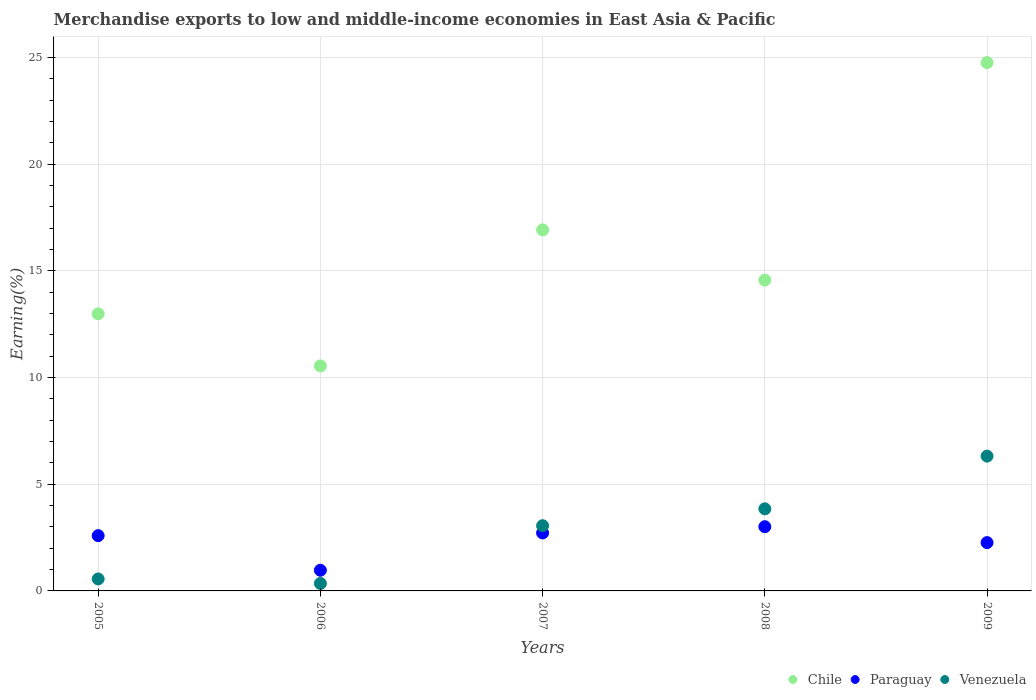How many different coloured dotlines are there?
Your answer should be very brief. 3. What is the percentage of amount earned from merchandise exports in Paraguay in 2008?
Your response must be concise. 3.01. Across all years, what is the maximum percentage of amount earned from merchandise exports in Chile?
Your response must be concise. 24.76. Across all years, what is the minimum percentage of amount earned from merchandise exports in Chile?
Your response must be concise. 10.54. What is the total percentage of amount earned from merchandise exports in Paraguay in the graph?
Ensure brevity in your answer.  11.55. What is the difference between the percentage of amount earned from merchandise exports in Chile in 2006 and that in 2008?
Offer a terse response. -4.02. What is the difference between the percentage of amount earned from merchandise exports in Venezuela in 2006 and the percentage of amount earned from merchandise exports in Paraguay in 2005?
Make the answer very short. -2.24. What is the average percentage of amount earned from merchandise exports in Chile per year?
Keep it short and to the point. 15.95. In the year 2006, what is the difference between the percentage of amount earned from merchandise exports in Paraguay and percentage of amount earned from merchandise exports in Venezuela?
Offer a terse response. 0.62. In how many years, is the percentage of amount earned from merchandise exports in Chile greater than 2 %?
Ensure brevity in your answer.  5. What is the ratio of the percentage of amount earned from merchandise exports in Paraguay in 2005 to that in 2006?
Your response must be concise. 2.68. What is the difference between the highest and the second highest percentage of amount earned from merchandise exports in Chile?
Your response must be concise. 7.84. What is the difference between the highest and the lowest percentage of amount earned from merchandise exports in Paraguay?
Provide a short and direct response. 2.04. In how many years, is the percentage of amount earned from merchandise exports in Paraguay greater than the average percentage of amount earned from merchandise exports in Paraguay taken over all years?
Give a very brief answer. 3. Is the sum of the percentage of amount earned from merchandise exports in Paraguay in 2008 and 2009 greater than the maximum percentage of amount earned from merchandise exports in Chile across all years?
Make the answer very short. No. Is it the case that in every year, the sum of the percentage of amount earned from merchandise exports in Venezuela and percentage of amount earned from merchandise exports in Paraguay  is greater than the percentage of amount earned from merchandise exports in Chile?
Keep it short and to the point. No. Does the percentage of amount earned from merchandise exports in Venezuela monotonically increase over the years?
Offer a very short reply. No. Is the percentage of amount earned from merchandise exports in Venezuela strictly less than the percentage of amount earned from merchandise exports in Chile over the years?
Your answer should be compact. Yes. Are the values on the major ticks of Y-axis written in scientific E-notation?
Provide a succinct answer. No. Does the graph contain any zero values?
Give a very brief answer. No. Where does the legend appear in the graph?
Provide a succinct answer. Bottom right. How are the legend labels stacked?
Provide a succinct answer. Horizontal. What is the title of the graph?
Provide a succinct answer. Merchandise exports to low and middle-income economies in East Asia & Pacific. Does "Least developed countries" appear as one of the legend labels in the graph?
Your answer should be compact. No. What is the label or title of the Y-axis?
Provide a short and direct response. Earning(%). What is the Earning(%) in Chile in 2005?
Provide a succinct answer. 12.98. What is the Earning(%) of Paraguay in 2005?
Offer a very short reply. 2.59. What is the Earning(%) in Venezuela in 2005?
Provide a succinct answer. 0.56. What is the Earning(%) of Chile in 2006?
Your answer should be very brief. 10.54. What is the Earning(%) of Paraguay in 2006?
Your response must be concise. 0.97. What is the Earning(%) in Venezuela in 2006?
Ensure brevity in your answer.  0.35. What is the Earning(%) of Chile in 2007?
Your response must be concise. 16.92. What is the Earning(%) in Paraguay in 2007?
Your answer should be compact. 2.72. What is the Earning(%) of Venezuela in 2007?
Offer a terse response. 3.06. What is the Earning(%) of Chile in 2008?
Offer a very short reply. 14.57. What is the Earning(%) of Paraguay in 2008?
Make the answer very short. 3.01. What is the Earning(%) in Venezuela in 2008?
Provide a short and direct response. 3.85. What is the Earning(%) in Chile in 2009?
Make the answer very short. 24.76. What is the Earning(%) in Paraguay in 2009?
Provide a succinct answer. 2.26. What is the Earning(%) of Venezuela in 2009?
Give a very brief answer. 6.32. Across all years, what is the maximum Earning(%) in Chile?
Offer a very short reply. 24.76. Across all years, what is the maximum Earning(%) of Paraguay?
Your answer should be very brief. 3.01. Across all years, what is the maximum Earning(%) in Venezuela?
Ensure brevity in your answer.  6.32. Across all years, what is the minimum Earning(%) in Chile?
Ensure brevity in your answer.  10.54. Across all years, what is the minimum Earning(%) in Paraguay?
Offer a terse response. 0.97. Across all years, what is the minimum Earning(%) of Venezuela?
Offer a very short reply. 0.35. What is the total Earning(%) of Chile in the graph?
Keep it short and to the point. 79.77. What is the total Earning(%) of Paraguay in the graph?
Make the answer very short. 11.55. What is the total Earning(%) of Venezuela in the graph?
Offer a terse response. 14.13. What is the difference between the Earning(%) of Chile in 2005 and that in 2006?
Keep it short and to the point. 2.44. What is the difference between the Earning(%) in Paraguay in 2005 and that in 2006?
Provide a succinct answer. 1.62. What is the difference between the Earning(%) of Venezuela in 2005 and that in 2006?
Ensure brevity in your answer.  0.21. What is the difference between the Earning(%) in Chile in 2005 and that in 2007?
Your answer should be compact. -3.93. What is the difference between the Earning(%) of Paraguay in 2005 and that in 2007?
Keep it short and to the point. -0.13. What is the difference between the Earning(%) of Venezuela in 2005 and that in 2007?
Keep it short and to the point. -2.49. What is the difference between the Earning(%) in Chile in 2005 and that in 2008?
Your answer should be compact. -1.58. What is the difference between the Earning(%) in Paraguay in 2005 and that in 2008?
Your response must be concise. -0.42. What is the difference between the Earning(%) of Venezuela in 2005 and that in 2008?
Provide a succinct answer. -3.29. What is the difference between the Earning(%) in Chile in 2005 and that in 2009?
Your answer should be compact. -11.77. What is the difference between the Earning(%) of Paraguay in 2005 and that in 2009?
Provide a succinct answer. 0.33. What is the difference between the Earning(%) of Venezuela in 2005 and that in 2009?
Your answer should be very brief. -5.75. What is the difference between the Earning(%) in Chile in 2006 and that in 2007?
Give a very brief answer. -6.37. What is the difference between the Earning(%) of Paraguay in 2006 and that in 2007?
Your answer should be very brief. -1.75. What is the difference between the Earning(%) of Venezuela in 2006 and that in 2007?
Offer a very short reply. -2.71. What is the difference between the Earning(%) of Chile in 2006 and that in 2008?
Provide a succinct answer. -4.02. What is the difference between the Earning(%) of Paraguay in 2006 and that in 2008?
Offer a very short reply. -2.04. What is the difference between the Earning(%) in Venezuela in 2006 and that in 2008?
Keep it short and to the point. -3.5. What is the difference between the Earning(%) of Chile in 2006 and that in 2009?
Your answer should be compact. -14.21. What is the difference between the Earning(%) of Paraguay in 2006 and that in 2009?
Give a very brief answer. -1.3. What is the difference between the Earning(%) in Venezuela in 2006 and that in 2009?
Make the answer very short. -5.97. What is the difference between the Earning(%) of Chile in 2007 and that in 2008?
Give a very brief answer. 2.35. What is the difference between the Earning(%) in Paraguay in 2007 and that in 2008?
Provide a succinct answer. -0.29. What is the difference between the Earning(%) in Venezuela in 2007 and that in 2008?
Offer a very short reply. -0.79. What is the difference between the Earning(%) of Chile in 2007 and that in 2009?
Give a very brief answer. -7.84. What is the difference between the Earning(%) in Paraguay in 2007 and that in 2009?
Make the answer very short. 0.45. What is the difference between the Earning(%) of Venezuela in 2007 and that in 2009?
Your response must be concise. -3.26. What is the difference between the Earning(%) in Chile in 2008 and that in 2009?
Provide a succinct answer. -10.19. What is the difference between the Earning(%) of Paraguay in 2008 and that in 2009?
Offer a terse response. 0.75. What is the difference between the Earning(%) of Venezuela in 2008 and that in 2009?
Provide a short and direct response. -2.47. What is the difference between the Earning(%) of Chile in 2005 and the Earning(%) of Paraguay in 2006?
Your answer should be compact. 12.02. What is the difference between the Earning(%) of Chile in 2005 and the Earning(%) of Venezuela in 2006?
Give a very brief answer. 12.64. What is the difference between the Earning(%) of Paraguay in 2005 and the Earning(%) of Venezuela in 2006?
Offer a very short reply. 2.24. What is the difference between the Earning(%) of Chile in 2005 and the Earning(%) of Paraguay in 2007?
Offer a very short reply. 10.27. What is the difference between the Earning(%) in Chile in 2005 and the Earning(%) in Venezuela in 2007?
Provide a succinct answer. 9.93. What is the difference between the Earning(%) in Paraguay in 2005 and the Earning(%) in Venezuela in 2007?
Provide a succinct answer. -0.47. What is the difference between the Earning(%) of Chile in 2005 and the Earning(%) of Paraguay in 2008?
Offer a terse response. 9.97. What is the difference between the Earning(%) in Chile in 2005 and the Earning(%) in Venezuela in 2008?
Your answer should be compact. 9.14. What is the difference between the Earning(%) in Paraguay in 2005 and the Earning(%) in Venezuela in 2008?
Offer a terse response. -1.26. What is the difference between the Earning(%) in Chile in 2005 and the Earning(%) in Paraguay in 2009?
Ensure brevity in your answer.  10.72. What is the difference between the Earning(%) in Chile in 2005 and the Earning(%) in Venezuela in 2009?
Ensure brevity in your answer.  6.67. What is the difference between the Earning(%) in Paraguay in 2005 and the Earning(%) in Venezuela in 2009?
Offer a very short reply. -3.73. What is the difference between the Earning(%) in Chile in 2006 and the Earning(%) in Paraguay in 2007?
Provide a short and direct response. 7.83. What is the difference between the Earning(%) of Chile in 2006 and the Earning(%) of Venezuela in 2007?
Your response must be concise. 7.49. What is the difference between the Earning(%) of Paraguay in 2006 and the Earning(%) of Venezuela in 2007?
Offer a terse response. -2.09. What is the difference between the Earning(%) of Chile in 2006 and the Earning(%) of Paraguay in 2008?
Ensure brevity in your answer.  7.53. What is the difference between the Earning(%) of Chile in 2006 and the Earning(%) of Venezuela in 2008?
Offer a terse response. 6.7. What is the difference between the Earning(%) of Paraguay in 2006 and the Earning(%) of Venezuela in 2008?
Make the answer very short. -2.88. What is the difference between the Earning(%) of Chile in 2006 and the Earning(%) of Paraguay in 2009?
Offer a terse response. 8.28. What is the difference between the Earning(%) of Chile in 2006 and the Earning(%) of Venezuela in 2009?
Offer a terse response. 4.23. What is the difference between the Earning(%) of Paraguay in 2006 and the Earning(%) of Venezuela in 2009?
Your answer should be very brief. -5.35. What is the difference between the Earning(%) of Chile in 2007 and the Earning(%) of Paraguay in 2008?
Offer a very short reply. 13.91. What is the difference between the Earning(%) of Chile in 2007 and the Earning(%) of Venezuela in 2008?
Your answer should be very brief. 13.07. What is the difference between the Earning(%) in Paraguay in 2007 and the Earning(%) in Venezuela in 2008?
Offer a terse response. -1.13. What is the difference between the Earning(%) of Chile in 2007 and the Earning(%) of Paraguay in 2009?
Keep it short and to the point. 14.65. What is the difference between the Earning(%) in Chile in 2007 and the Earning(%) in Venezuela in 2009?
Your answer should be very brief. 10.6. What is the difference between the Earning(%) of Paraguay in 2007 and the Earning(%) of Venezuela in 2009?
Provide a succinct answer. -3.6. What is the difference between the Earning(%) in Chile in 2008 and the Earning(%) in Paraguay in 2009?
Keep it short and to the point. 12.3. What is the difference between the Earning(%) of Chile in 2008 and the Earning(%) of Venezuela in 2009?
Offer a very short reply. 8.25. What is the difference between the Earning(%) of Paraguay in 2008 and the Earning(%) of Venezuela in 2009?
Make the answer very short. -3.31. What is the average Earning(%) of Chile per year?
Provide a succinct answer. 15.95. What is the average Earning(%) in Paraguay per year?
Your answer should be very brief. 2.31. What is the average Earning(%) in Venezuela per year?
Your answer should be compact. 2.83. In the year 2005, what is the difference between the Earning(%) of Chile and Earning(%) of Paraguay?
Provide a short and direct response. 10.4. In the year 2005, what is the difference between the Earning(%) of Chile and Earning(%) of Venezuela?
Provide a short and direct response. 12.42. In the year 2005, what is the difference between the Earning(%) in Paraguay and Earning(%) in Venezuela?
Give a very brief answer. 2.03. In the year 2006, what is the difference between the Earning(%) in Chile and Earning(%) in Paraguay?
Your answer should be very brief. 9.58. In the year 2006, what is the difference between the Earning(%) in Chile and Earning(%) in Venezuela?
Keep it short and to the point. 10.19. In the year 2006, what is the difference between the Earning(%) in Paraguay and Earning(%) in Venezuela?
Keep it short and to the point. 0.62. In the year 2007, what is the difference between the Earning(%) of Chile and Earning(%) of Paraguay?
Your response must be concise. 14.2. In the year 2007, what is the difference between the Earning(%) of Chile and Earning(%) of Venezuela?
Make the answer very short. 13.86. In the year 2007, what is the difference between the Earning(%) in Paraguay and Earning(%) in Venezuela?
Make the answer very short. -0.34. In the year 2008, what is the difference between the Earning(%) in Chile and Earning(%) in Paraguay?
Provide a short and direct response. 11.56. In the year 2008, what is the difference between the Earning(%) of Chile and Earning(%) of Venezuela?
Offer a terse response. 10.72. In the year 2008, what is the difference between the Earning(%) in Paraguay and Earning(%) in Venezuela?
Your response must be concise. -0.84. In the year 2009, what is the difference between the Earning(%) of Chile and Earning(%) of Paraguay?
Give a very brief answer. 22.49. In the year 2009, what is the difference between the Earning(%) of Chile and Earning(%) of Venezuela?
Make the answer very short. 18.44. In the year 2009, what is the difference between the Earning(%) in Paraguay and Earning(%) in Venezuela?
Your answer should be very brief. -4.05. What is the ratio of the Earning(%) of Chile in 2005 to that in 2006?
Your answer should be very brief. 1.23. What is the ratio of the Earning(%) of Paraguay in 2005 to that in 2006?
Provide a succinct answer. 2.68. What is the ratio of the Earning(%) in Venezuela in 2005 to that in 2006?
Ensure brevity in your answer.  1.61. What is the ratio of the Earning(%) of Chile in 2005 to that in 2007?
Ensure brevity in your answer.  0.77. What is the ratio of the Earning(%) of Paraguay in 2005 to that in 2007?
Your response must be concise. 0.95. What is the ratio of the Earning(%) of Venezuela in 2005 to that in 2007?
Your answer should be compact. 0.18. What is the ratio of the Earning(%) in Chile in 2005 to that in 2008?
Give a very brief answer. 0.89. What is the ratio of the Earning(%) in Paraguay in 2005 to that in 2008?
Keep it short and to the point. 0.86. What is the ratio of the Earning(%) in Venezuela in 2005 to that in 2008?
Make the answer very short. 0.15. What is the ratio of the Earning(%) of Chile in 2005 to that in 2009?
Ensure brevity in your answer.  0.52. What is the ratio of the Earning(%) of Paraguay in 2005 to that in 2009?
Keep it short and to the point. 1.14. What is the ratio of the Earning(%) in Venezuela in 2005 to that in 2009?
Provide a succinct answer. 0.09. What is the ratio of the Earning(%) in Chile in 2006 to that in 2007?
Your response must be concise. 0.62. What is the ratio of the Earning(%) of Paraguay in 2006 to that in 2007?
Give a very brief answer. 0.36. What is the ratio of the Earning(%) in Venezuela in 2006 to that in 2007?
Your answer should be compact. 0.11. What is the ratio of the Earning(%) in Chile in 2006 to that in 2008?
Keep it short and to the point. 0.72. What is the ratio of the Earning(%) of Paraguay in 2006 to that in 2008?
Provide a succinct answer. 0.32. What is the ratio of the Earning(%) of Venezuela in 2006 to that in 2008?
Provide a short and direct response. 0.09. What is the ratio of the Earning(%) of Chile in 2006 to that in 2009?
Your answer should be compact. 0.43. What is the ratio of the Earning(%) of Paraguay in 2006 to that in 2009?
Give a very brief answer. 0.43. What is the ratio of the Earning(%) in Venezuela in 2006 to that in 2009?
Provide a succinct answer. 0.06. What is the ratio of the Earning(%) in Chile in 2007 to that in 2008?
Give a very brief answer. 1.16. What is the ratio of the Earning(%) in Paraguay in 2007 to that in 2008?
Provide a succinct answer. 0.9. What is the ratio of the Earning(%) of Venezuela in 2007 to that in 2008?
Your answer should be very brief. 0.79. What is the ratio of the Earning(%) in Chile in 2007 to that in 2009?
Your response must be concise. 0.68. What is the ratio of the Earning(%) in Paraguay in 2007 to that in 2009?
Offer a terse response. 1.2. What is the ratio of the Earning(%) of Venezuela in 2007 to that in 2009?
Your answer should be compact. 0.48. What is the ratio of the Earning(%) of Chile in 2008 to that in 2009?
Keep it short and to the point. 0.59. What is the ratio of the Earning(%) of Paraguay in 2008 to that in 2009?
Your answer should be very brief. 1.33. What is the ratio of the Earning(%) of Venezuela in 2008 to that in 2009?
Your answer should be very brief. 0.61. What is the difference between the highest and the second highest Earning(%) of Chile?
Your answer should be compact. 7.84. What is the difference between the highest and the second highest Earning(%) in Paraguay?
Ensure brevity in your answer.  0.29. What is the difference between the highest and the second highest Earning(%) in Venezuela?
Ensure brevity in your answer.  2.47. What is the difference between the highest and the lowest Earning(%) in Chile?
Provide a succinct answer. 14.21. What is the difference between the highest and the lowest Earning(%) of Paraguay?
Provide a short and direct response. 2.04. What is the difference between the highest and the lowest Earning(%) of Venezuela?
Your response must be concise. 5.97. 